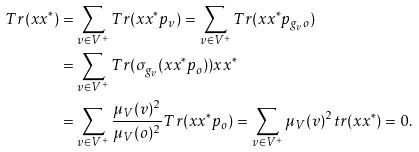<formula> <loc_0><loc_0><loc_500><loc_500>T r ( x x ^ { * } ) & = \sum _ { v \in V ^ { + } } T r ( x x ^ { * } p _ { v } ) = \sum _ { v \in V ^ { + } } T r ( x x ^ { * } p _ { g _ { v } o } ) \\ & = \sum _ { v \in V ^ { + } } T r ( \sigma _ { g _ { v } } ( x x ^ { * } p _ { o } ) ) x x ^ { * } \\ & = \sum _ { v \in V ^ { + } } \frac { \mu _ { V } ( v ) ^ { 2 } } { \mu _ { V } ( o ) ^ { 2 } } T r ( x x ^ { * } p _ { o } ) = \sum _ { v \in V ^ { + } } \mu _ { V } ( v ) ^ { 2 } t r ( x x ^ { * } ) = 0 .</formula> 